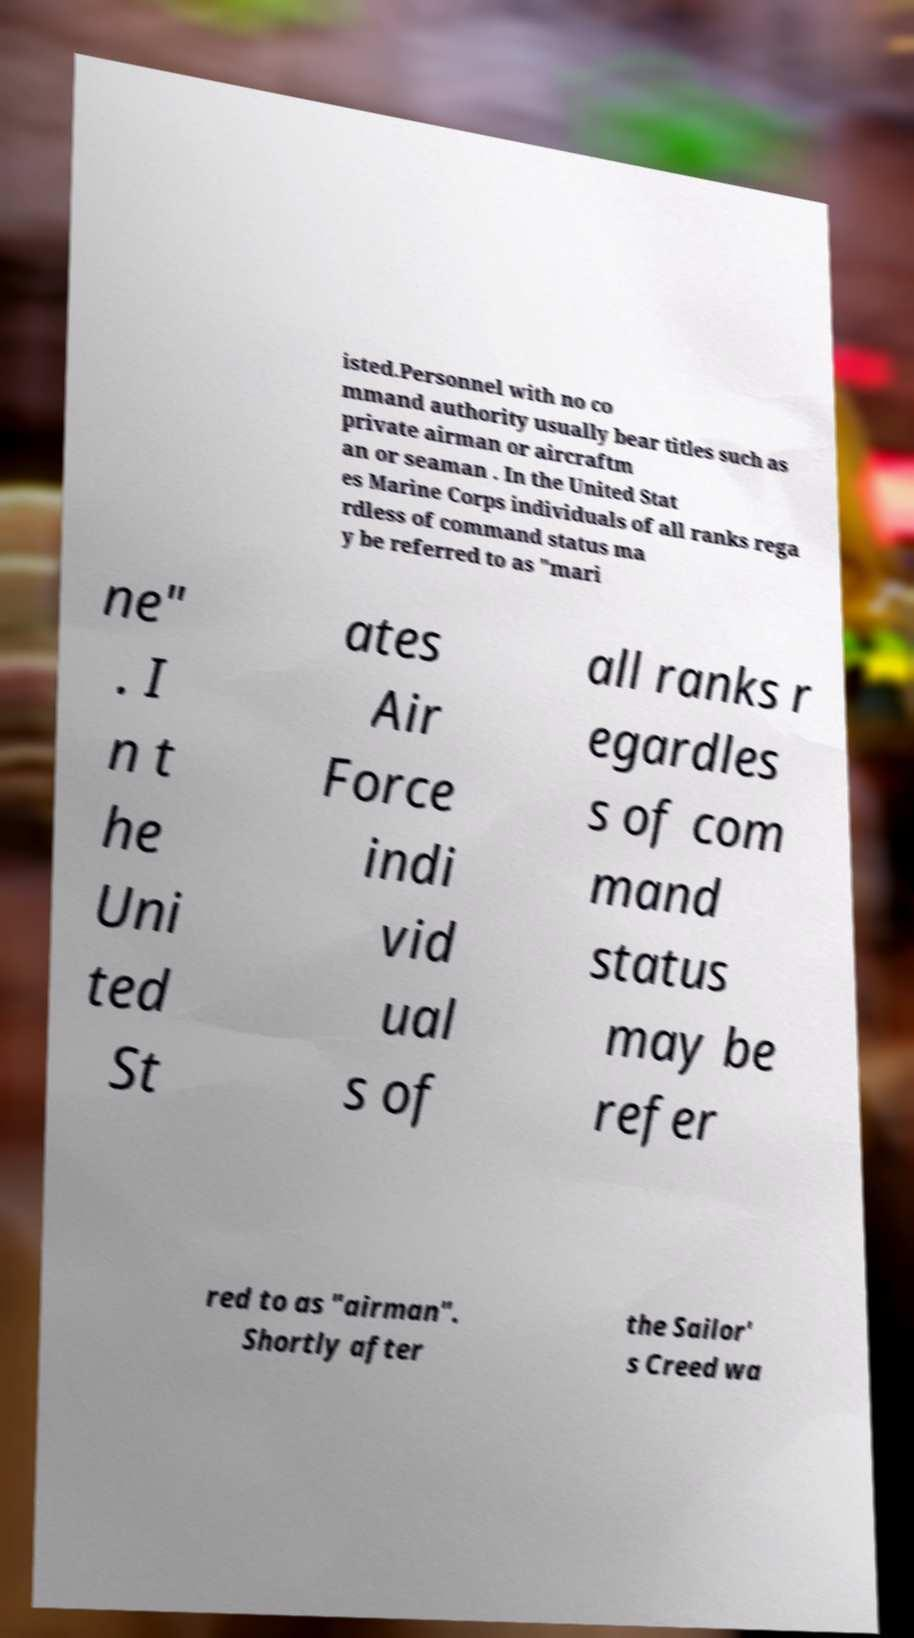Please identify and transcribe the text found in this image. isted.Personnel with no co mmand authority usually bear titles such as private airman or aircraftm an or seaman . In the United Stat es Marine Corps individuals of all ranks rega rdless of command status ma y be referred to as "mari ne" . I n t he Uni ted St ates Air Force indi vid ual s of all ranks r egardles s of com mand status may be refer red to as "airman". Shortly after the Sailor' s Creed wa 